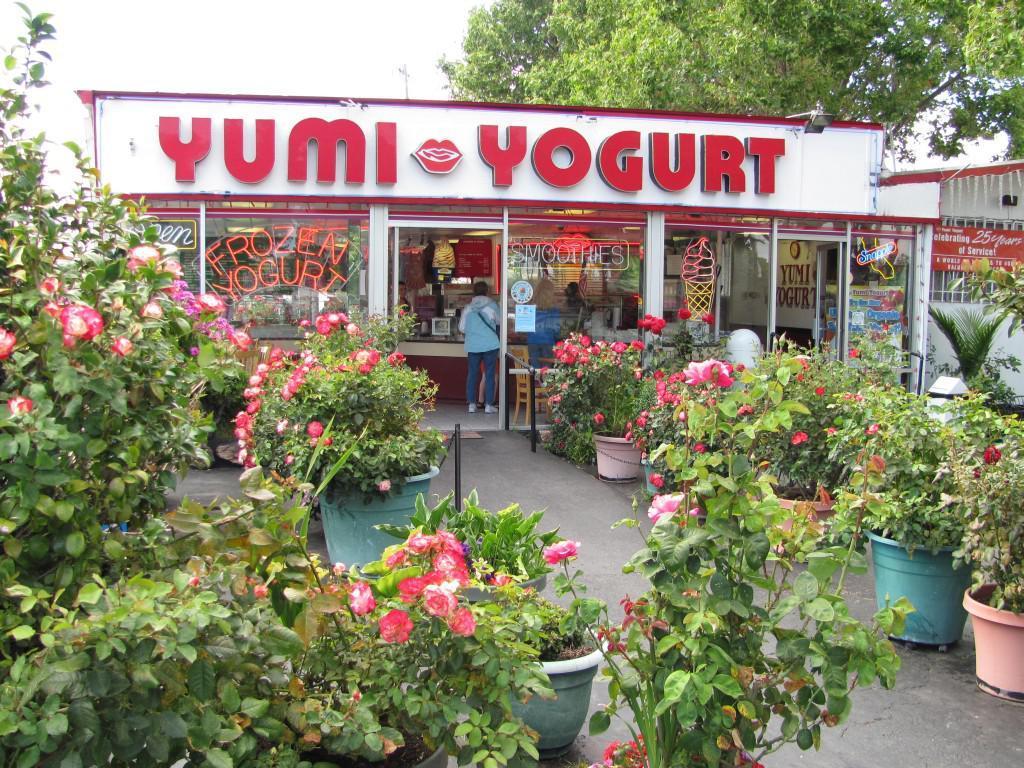Please provide a concise description of this image. In the foreground of this image, there are flowers to the plants. In the middle, there is a path and a building and we can a see a person standing. On the top, there is the tree and the sky. 